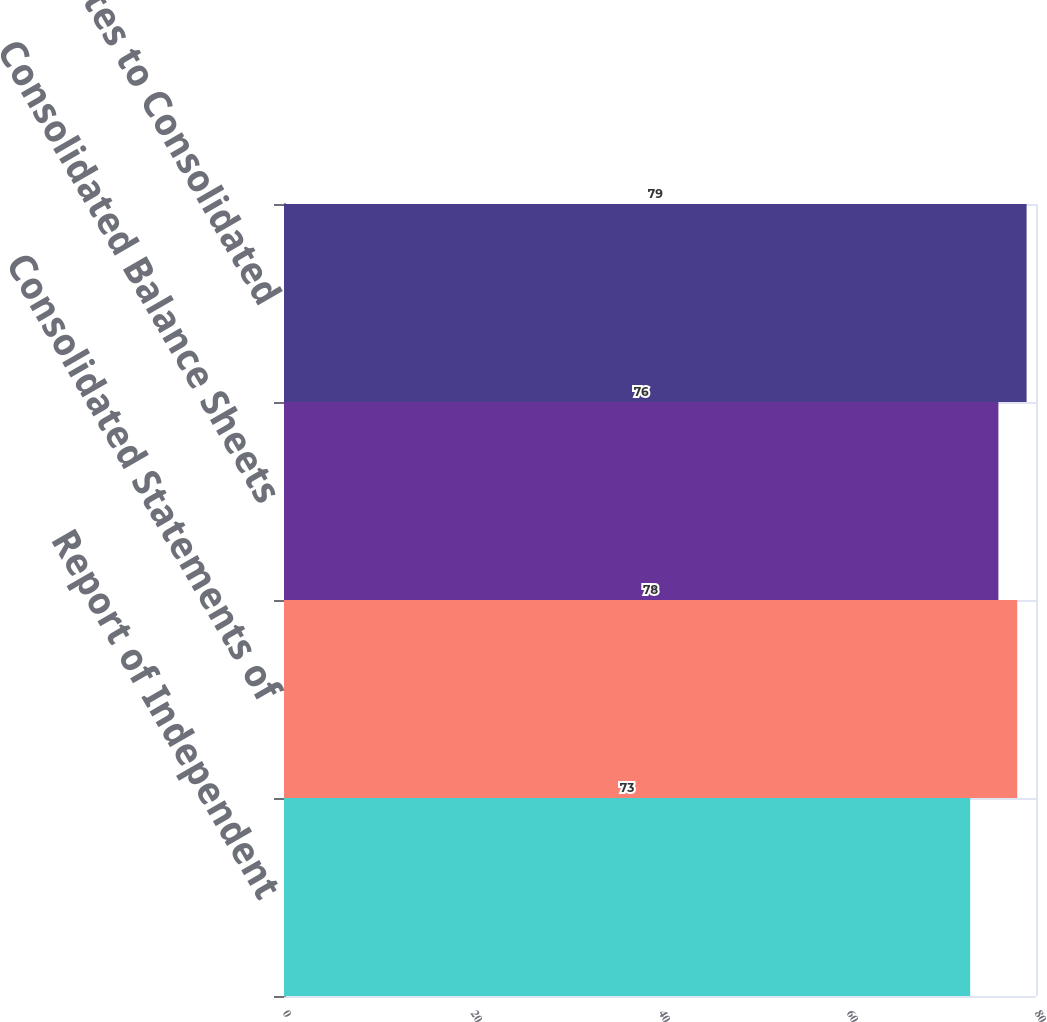Convert chart. <chart><loc_0><loc_0><loc_500><loc_500><bar_chart><fcel>Report of Independent<fcel>Consolidated Statements of<fcel>Consolidated Balance Sheets<fcel>Notes to Consolidated<nl><fcel>73<fcel>78<fcel>76<fcel>79<nl></chart> 